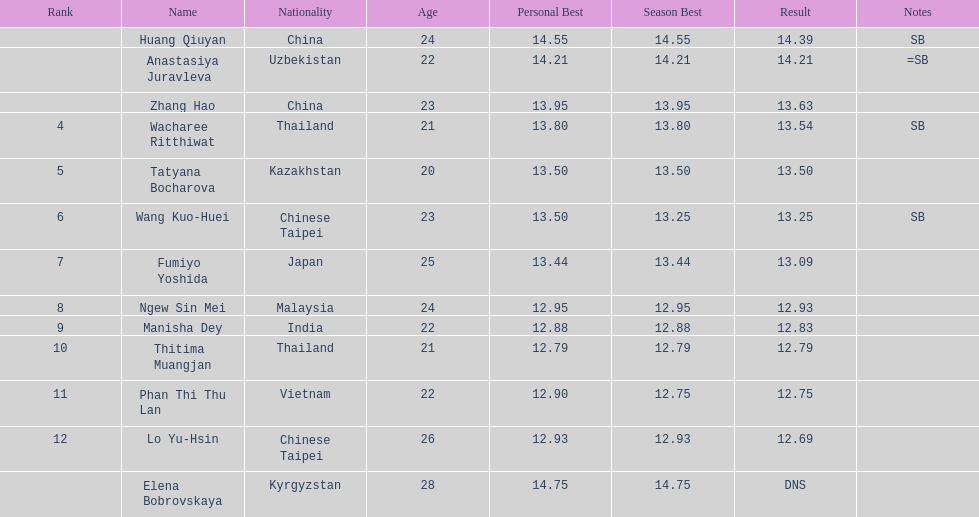How many points apart were the 1st place competitor and the 12th place competitor? 1.7. 